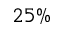<formula> <loc_0><loc_0><loc_500><loc_500>2 5 \%</formula> 